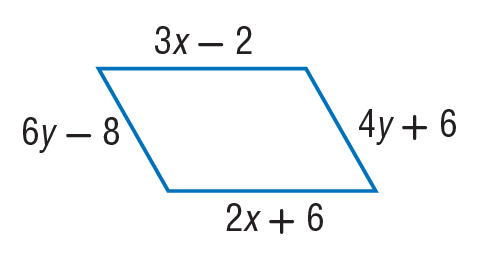Answer the mathemtical geometry problem and directly provide the correct option letter.
Question: Find y so that the quadrilateral is a parallelogram.
Choices: A: 7 B: 19 C: 25 D: 55 A 